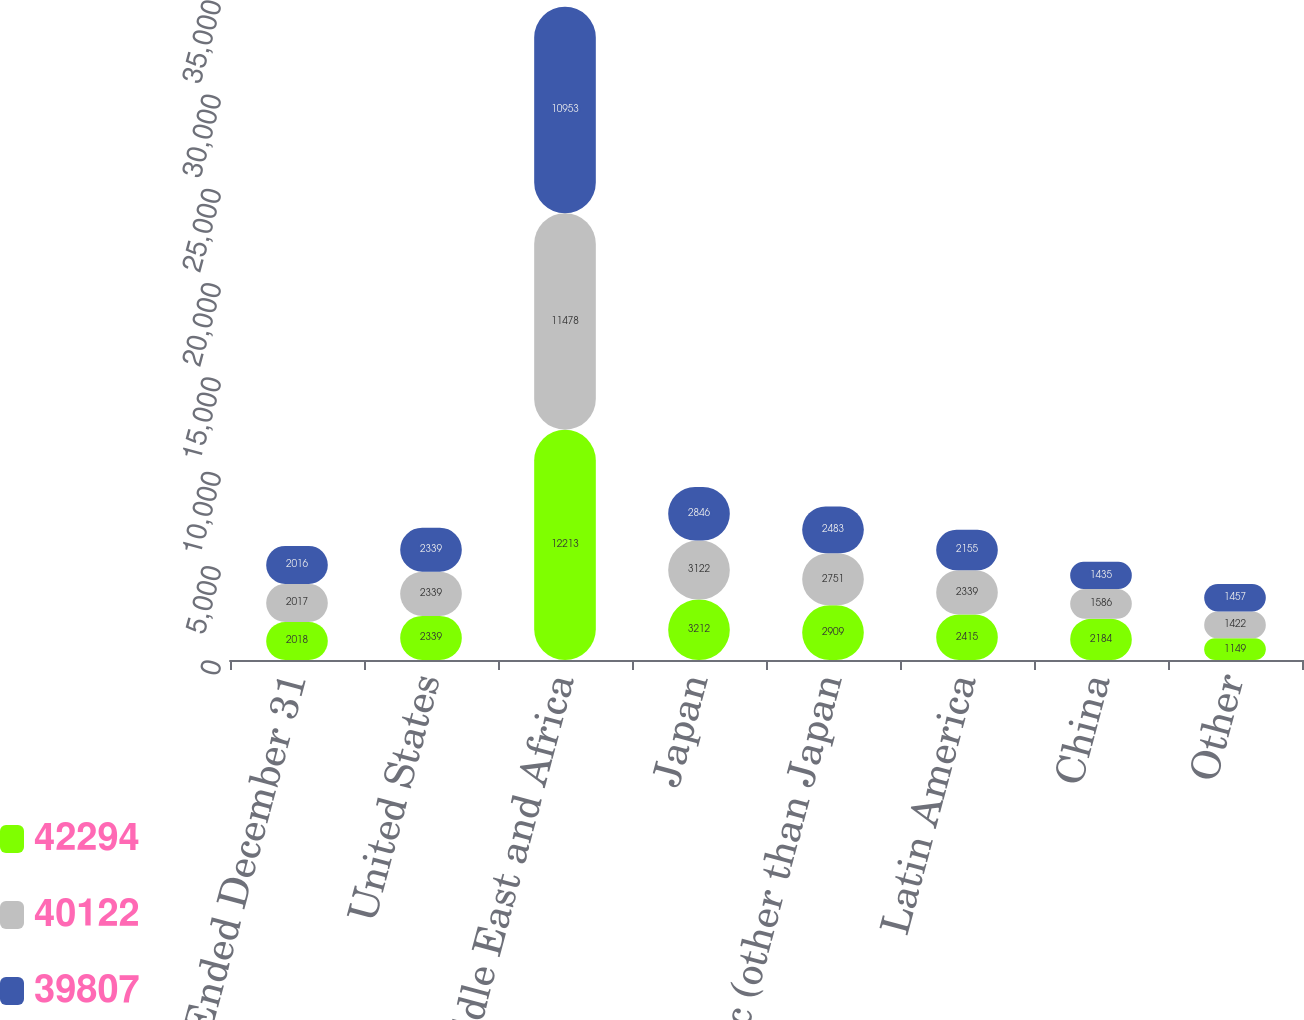Convert chart to OTSL. <chart><loc_0><loc_0><loc_500><loc_500><stacked_bar_chart><ecel><fcel>Years Ended December 31<fcel>United States<fcel>Europe Middle East and Africa<fcel>Japan<fcel>Asia Pacific (other than Japan<fcel>Latin America<fcel>China<fcel>Other<nl><fcel>42294<fcel>2018<fcel>2339<fcel>12213<fcel>3212<fcel>2909<fcel>2415<fcel>2184<fcel>1149<nl><fcel>40122<fcel>2017<fcel>2339<fcel>11478<fcel>3122<fcel>2751<fcel>2339<fcel>1586<fcel>1422<nl><fcel>39807<fcel>2016<fcel>2339<fcel>10953<fcel>2846<fcel>2483<fcel>2155<fcel>1435<fcel>1457<nl></chart> 